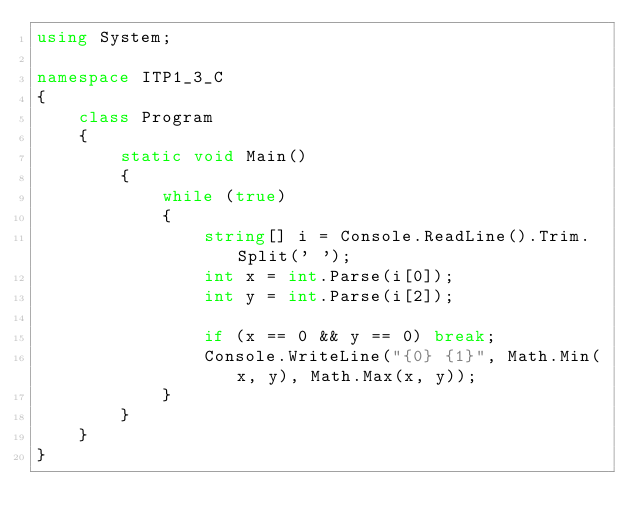Convert code to text. <code><loc_0><loc_0><loc_500><loc_500><_C#_>using System;

namespace ITP1_3_C
{
    class Program
    {
        static void Main()
        {
            while (true)
            {
                string[] i = Console.ReadLine().Trim.Split(' ');
                int x = int.Parse(i[0]);
                int y = int.Parse(i[2]);
                
                if (x == 0 && y == 0) break;
                Console.WriteLine("{0} {1}", Math.Min(x, y), Math.Max(x, y));
            }
        }
    }
}
</code> 